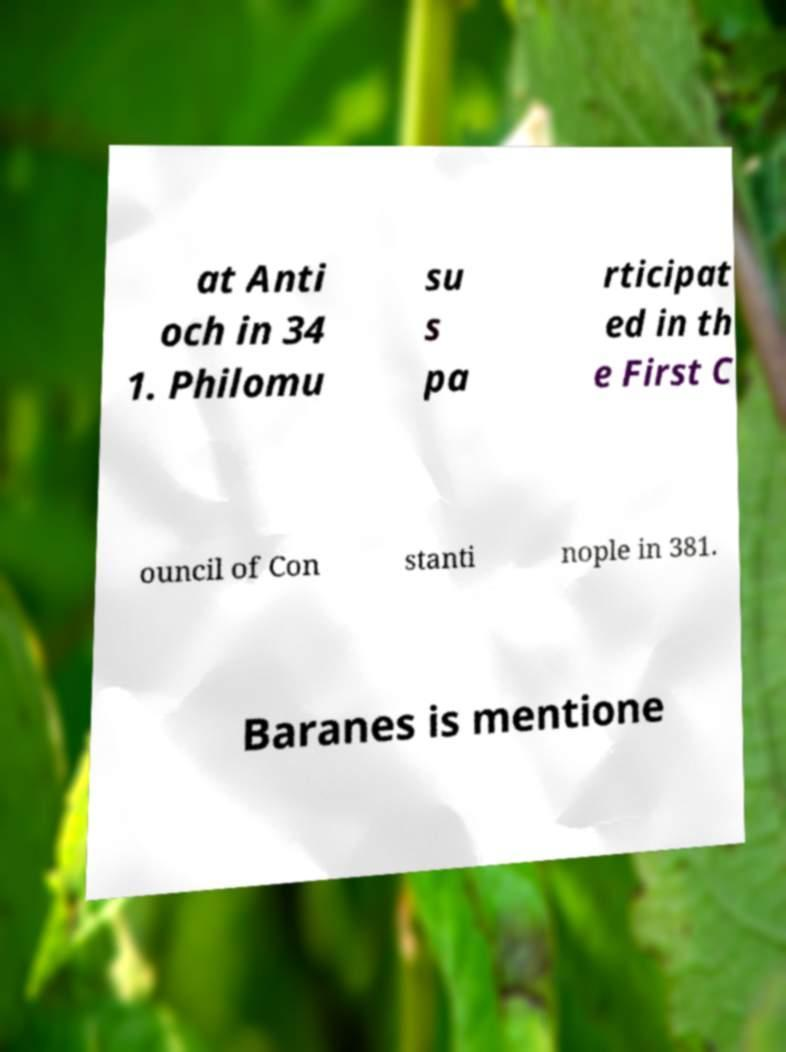Could you extract and type out the text from this image? at Anti och in 34 1. Philomu su s pa rticipat ed in th e First C ouncil of Con stanti nople in 381. Baranes is mentione 